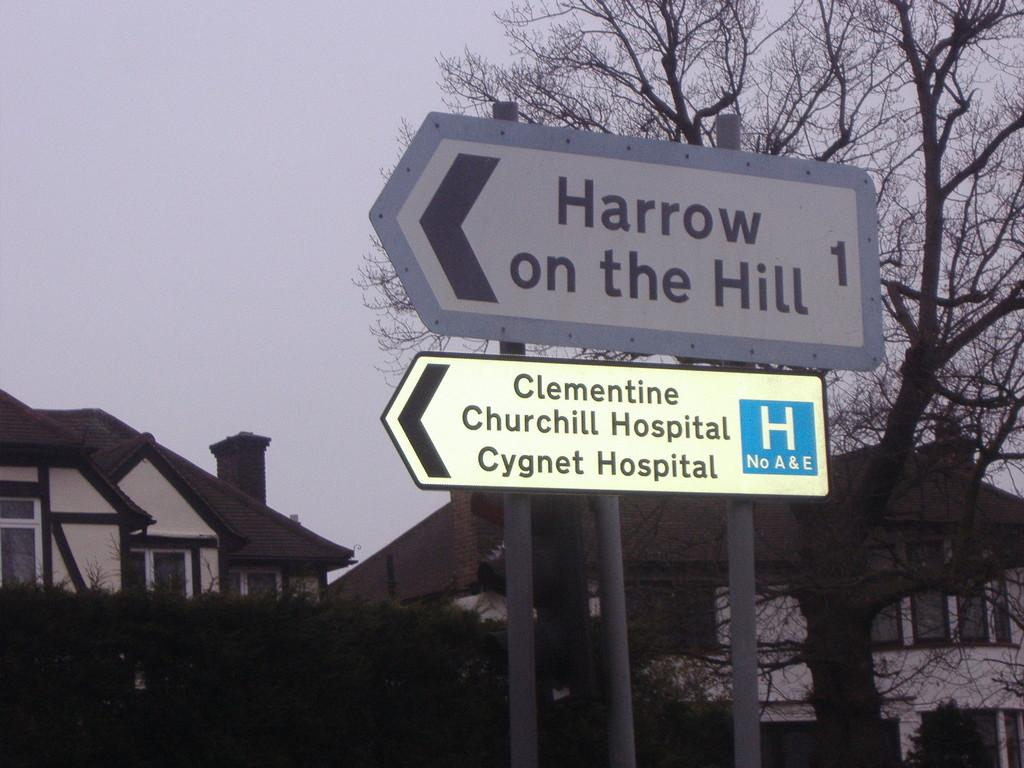What type of signage is present in the image? There are direction sign boards in the image. What are the sign boards pointing to? The sign boards are pointing to poles. What type of natural elements can be seen in the image? There are trees in the image. What type of structures are visible in the image? There are buildings with windows in the image. What is visible in the background of the image? The sky is visible in the background of the image. What type of pizzas are being served at the feast in the image? There is no feast or pizzas present in the image; it features direction sign boards, poles, trees, buildings, and the sky. 